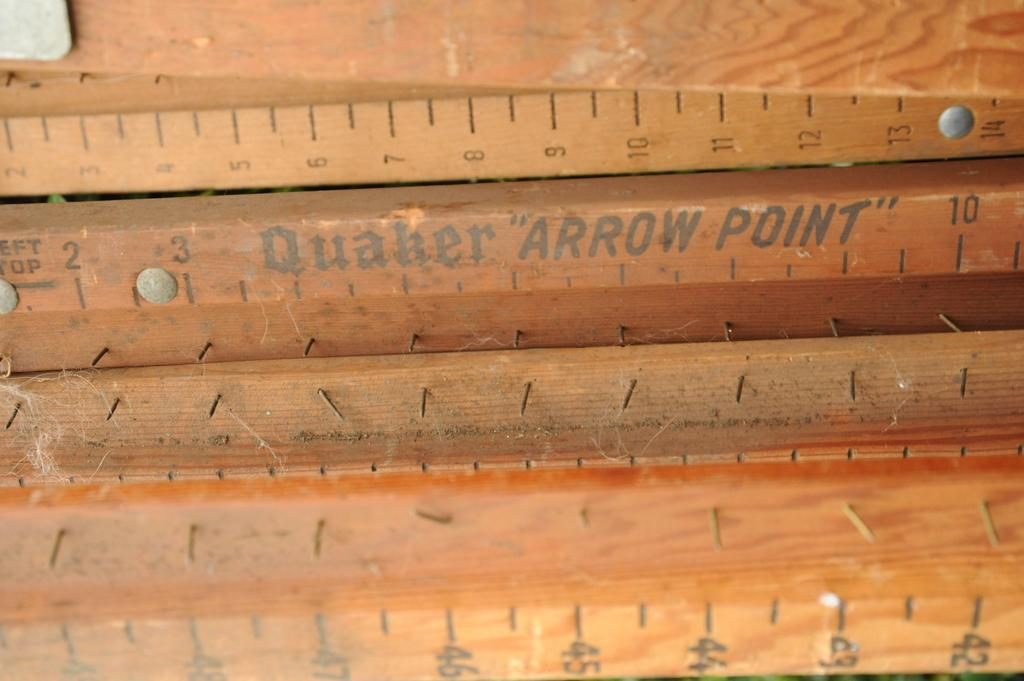<image>
Create a compact narrative representing the image presented. sections of quaker arrow point strips that hold down carpet 